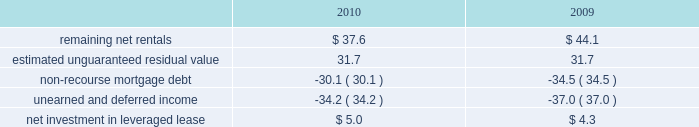Kimco realty corporation and subsidiaries notes to consolidated financial statements , continued investment in retail store leases 2014 the company has interests in various retail store leases relating to the anchor store premises in neighborhood and community shopping centers .
These premises have been sublet to retailers who lease the stores pursuant to net lease agreements .
Income from the investment in these retail store leases during the years ended december 31 , 2010 , 2009 and 2008 , was approximately $ 1.6 million , $ 0.8 million and $ 2.7 million , respectively .
These amounts represent sublease revenues during the years ended december 31 , 2010 , 2009 and 2008 , of approximately $ 5.9 million , $ 5.2 million and $ 7.1 million , respectively , less related expenses of $ 4.3 million , $ 4.4 million and $ 4.4 million , respectively .
The company 2019s future minimum revenues under the terms of all non-cancelable tenant subleases and future minimum obligations through the remaining terms of its retail store leases , assuming no new or renegotiated leases are executed for such premises , for future years are as follows ( in millions ) : 2011 , $ 5.2 and $ 3.4 ; 2012 , $ 4.1 and $ 2.6 ; 2013 , $ 3.8 and $ 2.3 ; 2014 , $ 2.9 and $ 1.7 ; 2015 , $ 2.1 and $ 1.3 , and thereafter , $ 2.8 and $ 1.6 , respectively .
Leveraged lease 2014 during june 2002 , the company acquired a 90% ( 90 % ) equity participation interest in an existing leveraged lease of 30 properties .
The properties are leased under a long-term bond-type net lease whose primary term expires in 2016 , with the lessee having certain renewal option rights .
The company 2019s cash equity investment was approximately $ 4.0 million .
This equity investment is reported as a net investment in leveraged lease in accordance with the fasb 2019s lease guidance .
As of december 31 , 2010 , 18 of these properties were sold , whereby the proceeds from the sales were used to pay down the mortgage debt by approximately $ 31.2 million and the remaining 12 properties were encumbered by third-party non-recourse debt of approximately $ 33.4 million that is scheduled to fully amortize during the primary term of the lease from a portion of the periodic net rents receivable under the net lease .
As an equity participant in the leveraged lease , the company has no recourse obligation for principal or interest payments on the debt , which is collateralized by a first mortgage lien on the properties and collateral assignment of the lease .
Accordingly , this obligation has been offset against the related net rental receivable under the lease .
At december 31 , 2010 and 2009 , the company 2019s net investment in the leveraged lease consisted of the following ( in millions ) : .
10 .
Variable interest entities : consolidated operating properties 2014 included within the company 2019s consolidated operating properties at december 31 , 2010 are four consolidated entities that are vies and for which the company is the primary beneficiary .
All of these entities have been established to own and operate real estate property .
The company 2019s involvement with these entities is through its majority ownership of the properties .
These entities were deemed vies primarily based on the fact that the voting rights of the equity investors are not proportional to their obligation to absorb expected losses or receive the expected residual returns of the entity and substantially all of the entity 2019s activities are conducted on behalf of the investor which has disproportionately fewer voting rights .
The company determined that it was the primary beneficiary of these vies as a result of its controlling financial interest .
During 2010 , the company sold two consolidated vie 2019s which the company was the primary beneficiary. .
As of dec 31 , 2010 , what was the average sale price , in millions , for the properties that were sold? 
Computations: (31.2 / 18)
Answer: 1.73333. 